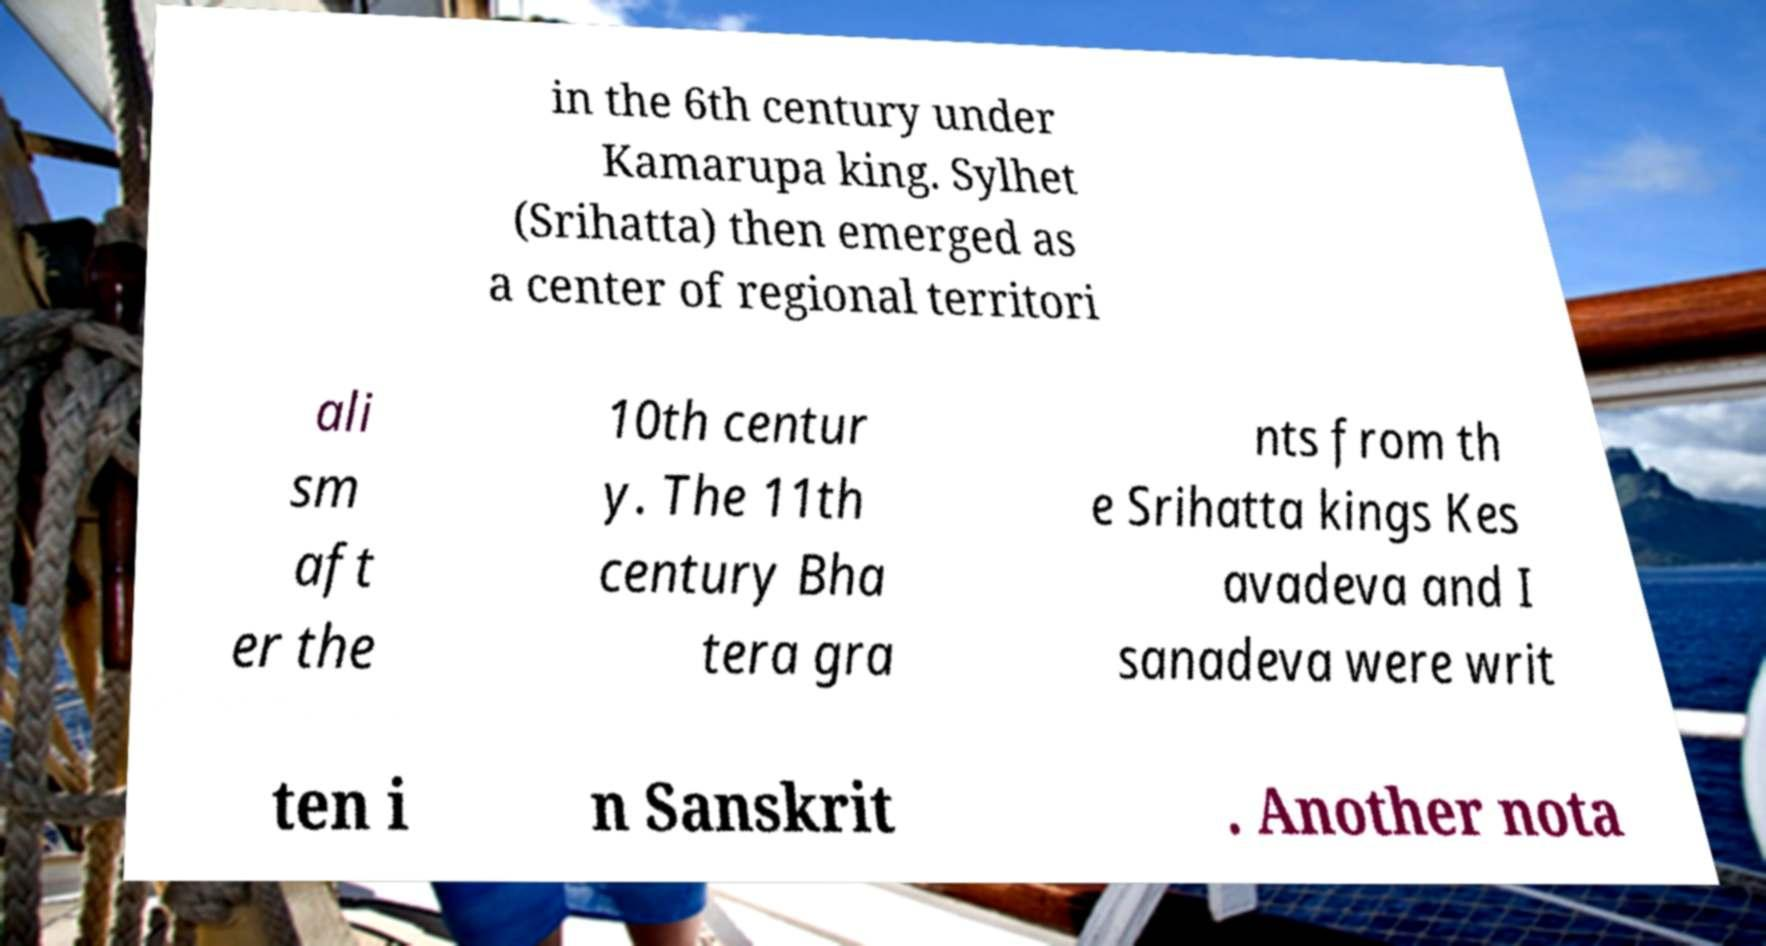Could you extract and type out the text from this image? in the 6th century under Kamarupa king. Sylhet (Srihatta) then emerged as a center of regional territori ali sm aft er the 10th centur y. The 11th century Bha tera gra nts from th e Srihatta kings Kes avadeva and I sanadeva were writ ten i n Sanskrit . Another nota 